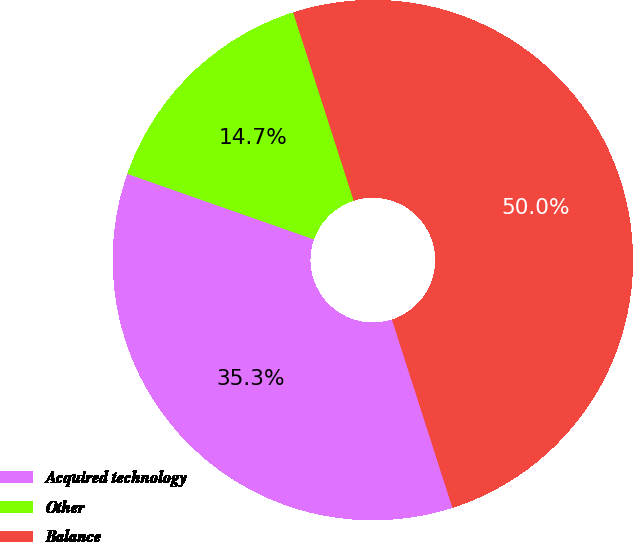Convert chart to OTSL. <chart><loc_0><loc_0><loc_500><loc_500><pie_chart><fcel>Acquired technology<fcel>Other<fcel>Balance<nl><fcel>35.33%<fcel>14.67%<fcel>50.0%<nl></chart> 